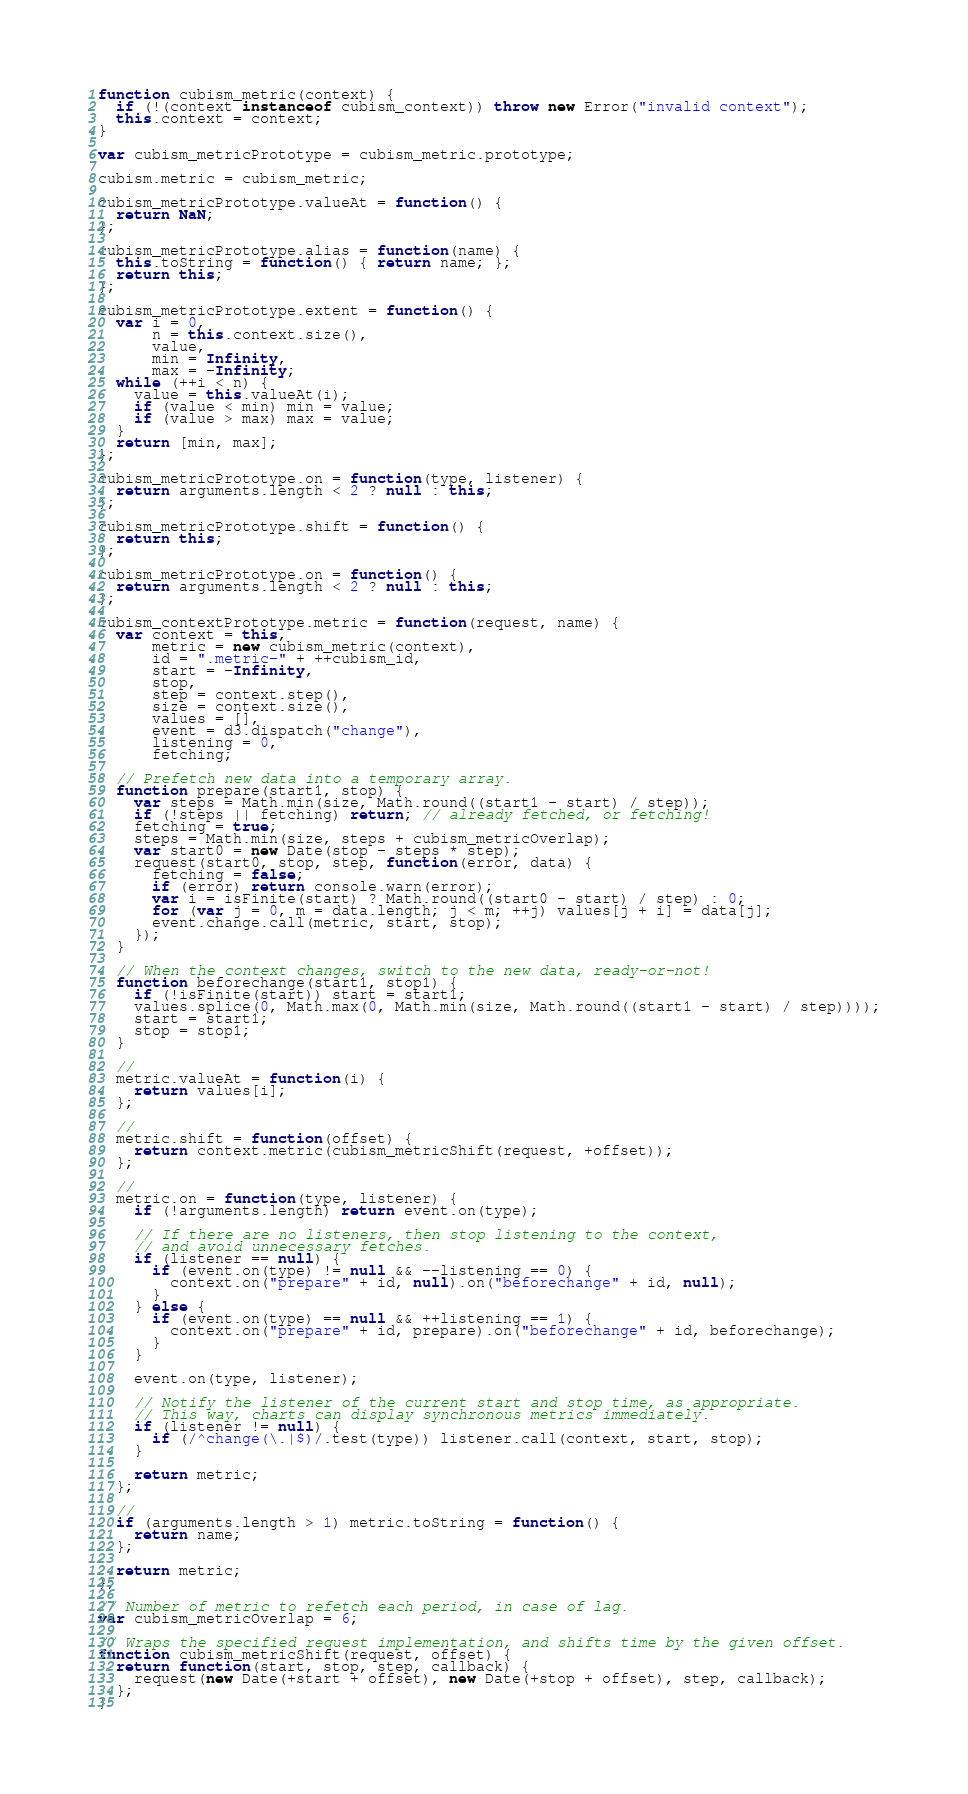Convert code to text. <code><loc_0><loc_0><loc_500><loc_500><_JavaScript_>function cubism_metric(context) {
  if (!(context instanceof cubism_context)) throw new Error("invalid context");
  this.context = context;
}

var cubism_metricPrototype = cubism_metric.prototype;

cubism.metric = cubism_metric;

cubism_metricPrototype.valueAt = function() {
  return NaN;
};

cubism_metricPrototype.alias = function(name) {
  this.toString = function() { return name; };
  return this;
};

cubism_metricPrototype.extent = function() {
  var i = 0,
      n = this.context.size(),
      value,
      min = Infinity,
      max = -Infinity;
  while (++i < n) {
    value = this.valueAt(i);
    if (value < min) min = value;
    if (value > max) max = value;
  }
  return [min, max];
};

cubism_metricPrototype.on = function(type, listener) {
  return arguments.length < 2 ? null : this;
};

cubism_metricPrototype.shift = function() {
  return this;
};

cubism_metricPrototype.on = function() {
  return arguments.length < 2 ? null : this;
};

cubism_contextPrototype.metric = function(request, name) {
  var context = this,
      metric = new cubism_metric(context),
      id = ".metric-" + ++cubism_id,
      start = -Infinity,
      stop,
      step = context.step(),
      size = context.size(),
      values = [],
      event = d3.dispatch("change"),
      listening = 0,
      fetching;

  // Prefetch new data into a temporary array.
  function prepare(start1, stop) {
    var steps = Math.min(size, Math.round((start1 - start) / step));
    if (!steps || fetching) return; // already fetched, or fetching!
    fetching = true;
    steps = Math.min(size, steps + cubism_metricOverlap);
    var start0 = new Date(stop - steps * step);
    request(start0, stop, step, function(error, data) {
      fetching = false;
      if (error) return console.warn(error);
      var i = isFinite(start) ? Math.round((start0 - start) / step) : 0;
      for (var j = 0, m = data.length; j < m; ++j) values[j + i] = data[j];
      event.change.call(metric, start, stop);
    });
  }

  // When the context changes, switch to the new data, ready-or-not!
  function beforechange(start1, stop1) {
    if (!isFinite(start)) start = start1;
    values.splice(0, Math.max(0, Math.min(size, Math.round((start1 - start) / step))));
    start = start1;
    stop = stop1;
  }

  //
  metric.valueAt = function(i) {
    return values[i];
  };

  //
  metric.shift = function(offset) {
    return context.metric(cubism_metricShift(request, +offset));
  };

  //
  metric.on = function(type, listener) {
    if (!arguments.length) return event.on(type);

    // If there are no listeners, then stop listening to the context,
    // and avoid unnecessary fetches.
    if (listener == null) {
      if (event.on(type) != null && --listening == 0) {
        context.on("prepare" + id, null).on("beforechange" + id, null);
      }
    } else {
      if (event.on(type) == null && ++listening == 1) {
        context.on("prepare" + id, prepare).on("beforechange" + id, beforechange);
      }
    }

    event.on(type, listener);

    // Notify the listener of the current start and stop time, as appropriate.
    // This way, charts can display synchronous metrics immediately.
    if (listener != null) {
      if (/^change(\.|$)/.test(type)) listener.call(context, start, stop);
    }

    return metric;
  };

  //
  if (arguments.length > 1) metric.toString = function() {
    return name;
  };

  return metric;
};

// Number of metric to refetch each period, in case of lag.
var cubism_metricOverlap = 6;

// Wraps the specified request implementation, and shifts time by the given offset.
function cubism_metricShift(request, offset) {
  return function(start, stop, step, callback) {
    request(new Date(+start + offset), new Date(+stop + offset), step, callback);
  };
}
</code> 